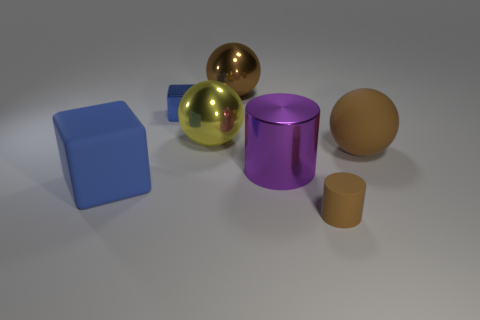What is the material of the purple thing that is the same size as the brown metallic ball?
Make the answer very short. Metal. What number of big yellow metal objects are there?
Offer a terse response. 1. There is a blue block behind the blue matte cube; what size is it?
Offer a very short reply. Small. Are there an equal number of tiny metallic blocks on the left side of the large block and large blue cubes?
Offer a terse response. No. Is there a green metal thing of the same shape as the tiny brown matte thing?
Provide a succinct answer. No. What shape is the thing that is both in front of the purple metallic object and on the right side of the large brown shiny sphere?
Keep it short and to the point. Cylinder. Does the tiny blue cube have the same material as the cylinder behind the big rubber block?
Offer a very short reply. Yes. Are there any cylinders in front of the large yellow metallic object?
Provide a short and direct response. Yes. How many objects are either large balls or large brown balls behind the small blue metallic cube?
Your answer should be compact. 3. There is a tiny shiny object behind the matte object that is in front of the blue rubber thing; what color is it?
Make the answer very short. Blue. 